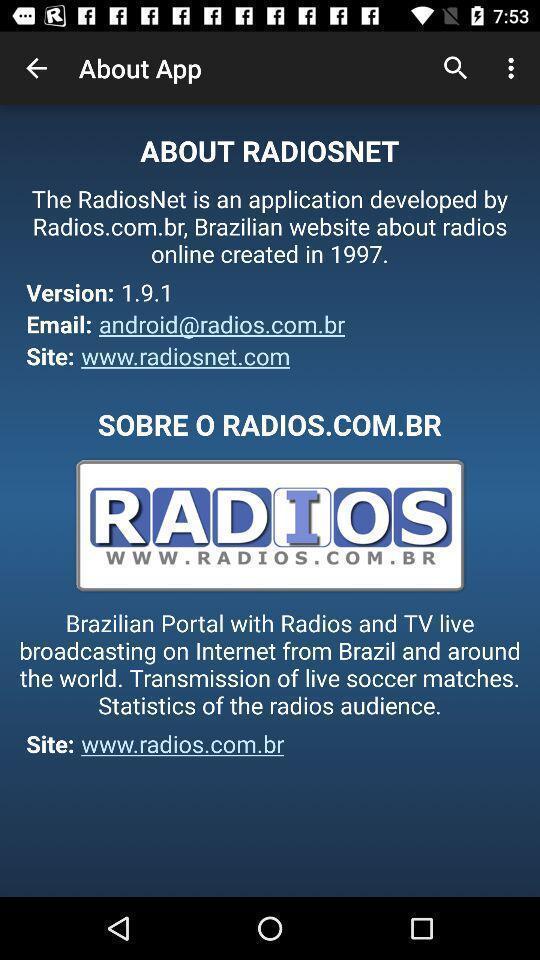Tell me what you see in this picture. Screen shows about details of radio app. 